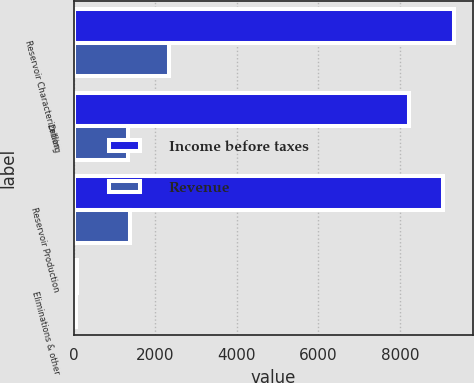Convert chart. <chart><loc_0><loc_0><loc_500><loc_500><stacked_bar_chart><ecel><fcel>Reservoir Characterization<fcel>Drilling<fcel>Reservoir Production<fcel>Eliminations & other<nl><fcel>Income before taxes<fcel>9321<fcel>8230<fcel>9053<fcel>69<nl><fcel>Revenue<fcel>2321<fcel>1334<fcel>1368<fcel>48<nl></chart> 